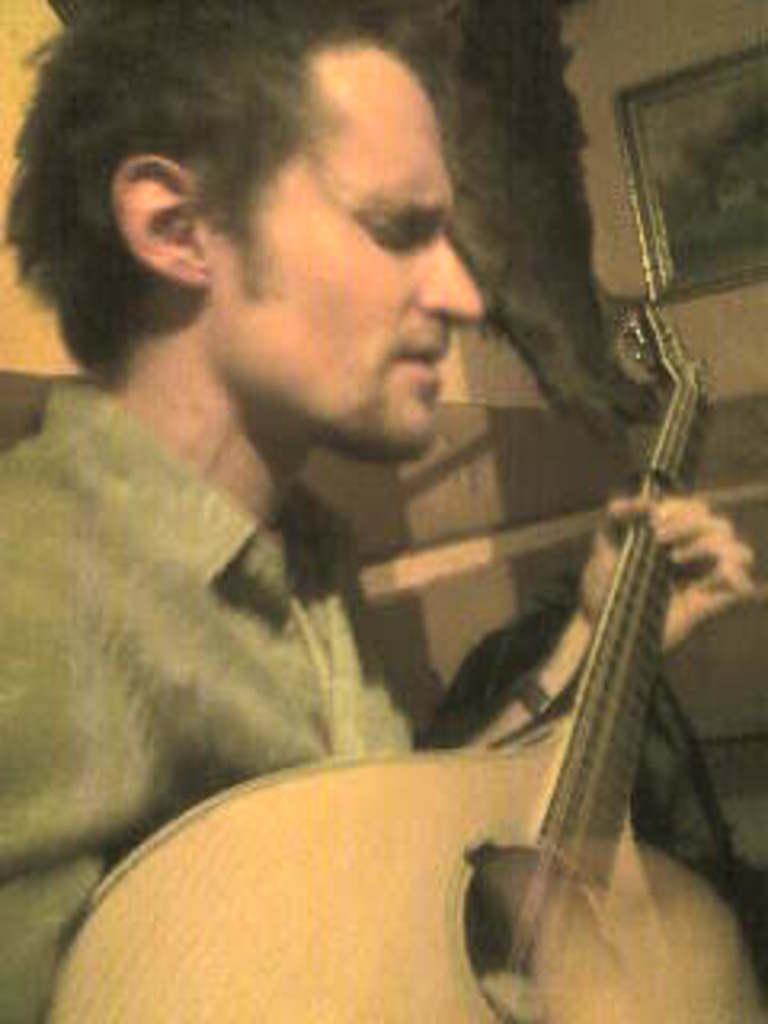What is the man in the image holding? The man is holding a guitar. What is located beside the man in the image? There is a wall beside the man. What can be seen attached to the wall in the image? There is a photo frame attached to the wall. What language is the man speaking in the image? There is no indication of the man speaking in the image, so it cannot be determined which language he might be using. 